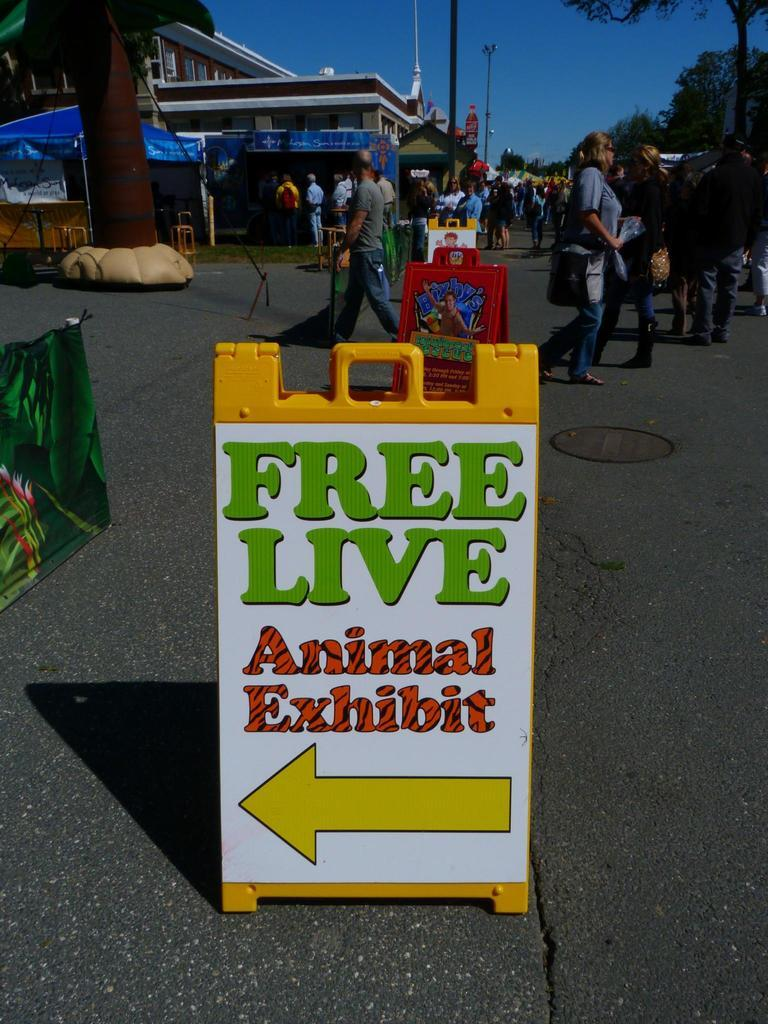How many people can be seen in the image? There are people in the image, but the exact number is not specified. What is placed on the road in the image? There are boards on the road in the image. What structures can be seen in the image? There are poles, a tent, and a building in the image. What type of inflatable object is present in the image? There is an inflatable tree in the image. What type of vegetation is visible in the image? There are trees in the image. What else can be seen in the image besides the mentioned objects? There are objects in the image, but their specific nature is not described. What is visible in the background of the image? The sky is visible in the background of the image. How many bubbles are floating around the inflatable tree in the image? There are no bubbles present in the image. What type of cake is being served at the event in the image? There is no event or cake present in the image. 